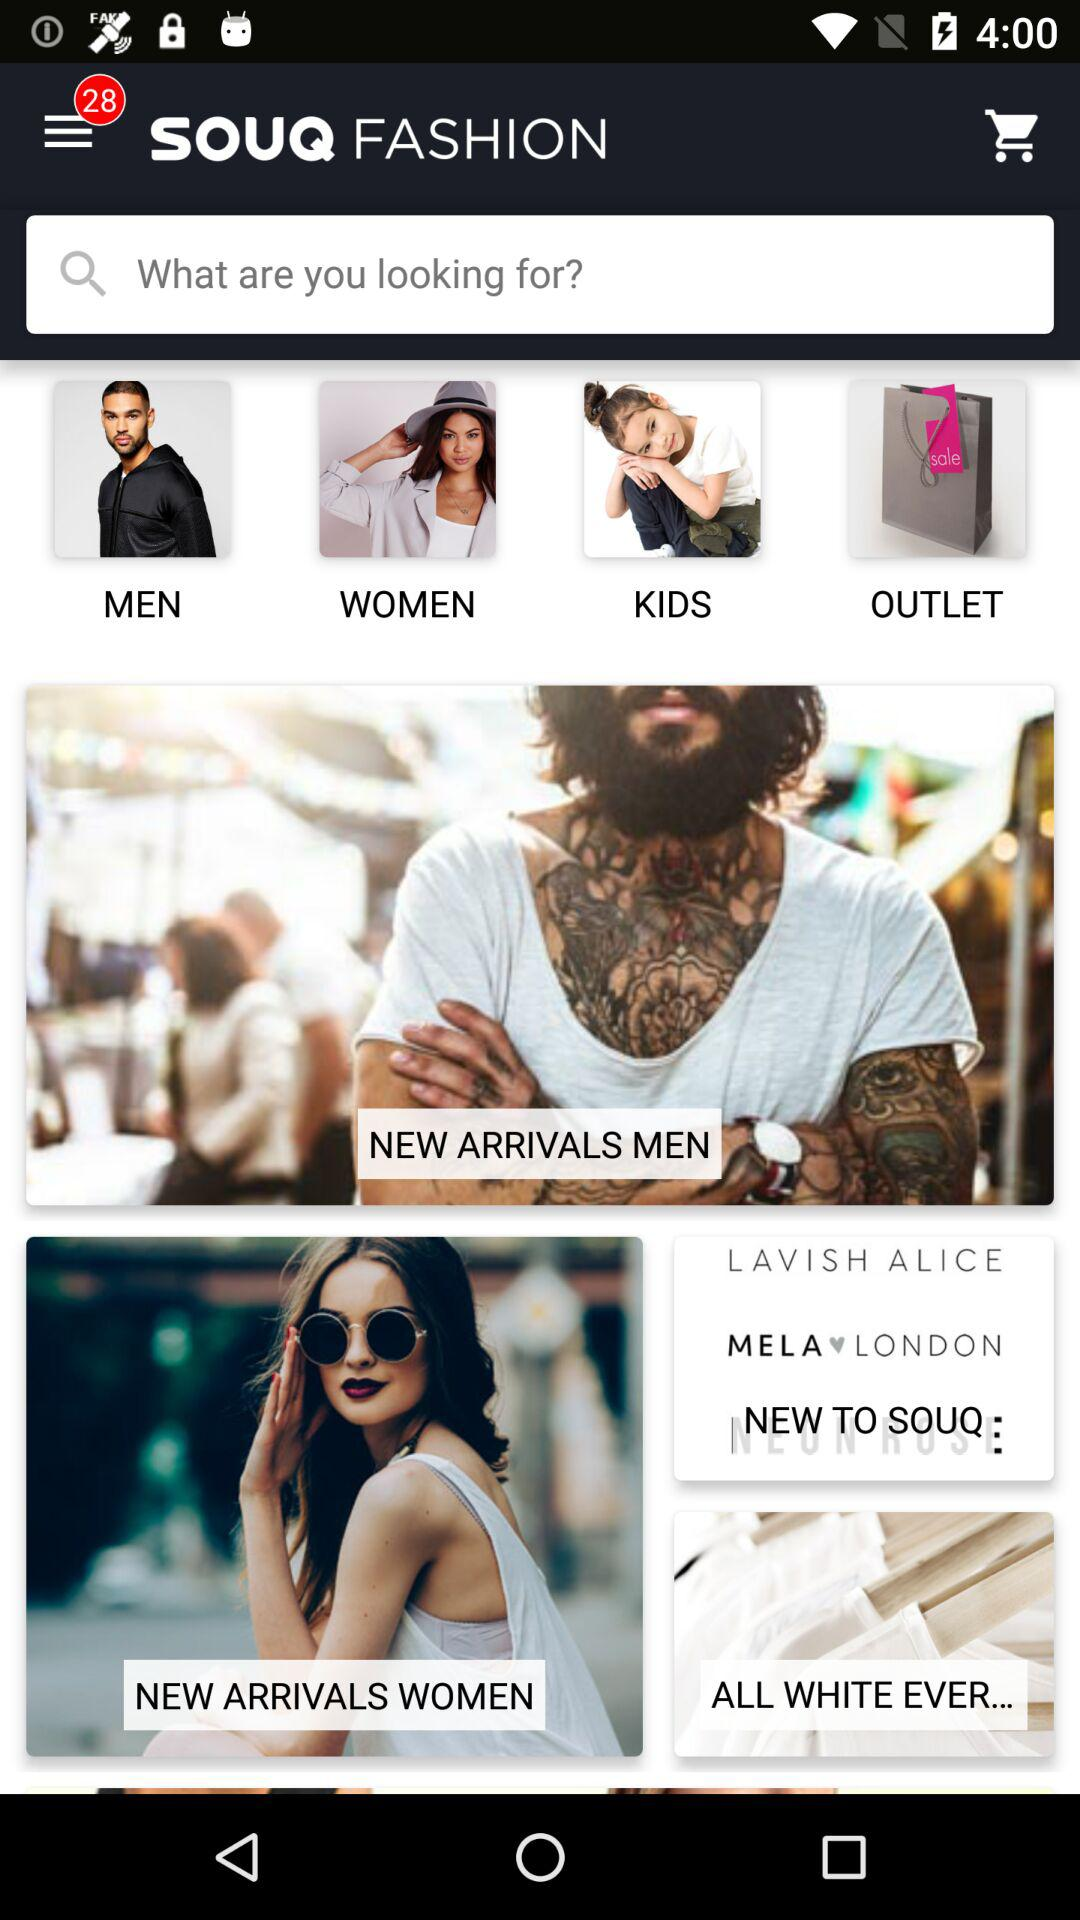Do they have any new arrivals for men?
When the provided information is insufficient, respond with <no answer>. <no answer> 